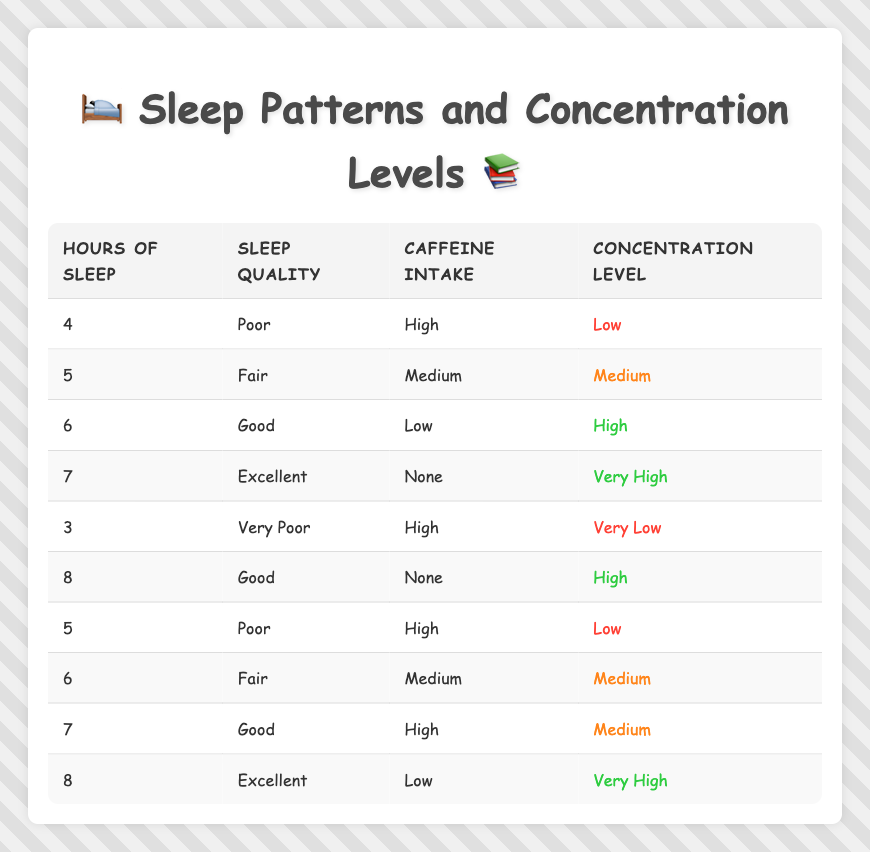What are the concentration levels associated with 4 hours of sleep? Looking at the table, under the row where "hours of sleep" is 4, the corresponding "concentration level" is listed as "low."
Answer: Low Is it true that having excellent sleep quality guarantees a very high concentration level? Yes, in the rows where sleep quality is marked as "excellent," the concentration levels are "very high" for both 7 and 8 hours of sleep. Therefore, it is true that excellent sleep quality correlates with very high concentration levels.
Answer: Yes How does an increase in caffeine intake affect concentration levels when sleep quality is poor? In the table, for "poor" sleep quality and "high" caffeine intake, the concentration is "low" (5 hours) and also "low" for 4 hours, indicating that high caffeine intake does not improve concentration when sleep quality is poor.
Answer: Low What is the average concentration level for sleep durations of 6 hours? There are two entries for "6 hours of sleep." One has "Good" quality and "Low" caffeine, resulting in a "high" concentration level. The second has "Fair" quality and "Medium" caffeine, resulting in a "medium" concentration level. The average would be calculated as follows: (high + medium) = (high is 3/5 and medium is 2/5, equivalent to (3+2)/2) = 2.5  So the average concentration level for 6 hours is "medium.”
Answer: Medium If a person sleeps for 8 hours and consumes no caffeine, what would you expect their concentration level to be? Referring to the table, for 8 hours of sleep with "Good" and "Excellent" quality and "none" caffeine intake, the "concentration level" is "high" and "very high" respectively. Thus, we can expect that 8 hours of sleep with no caffeine would likely lead to a high concentration level.
Answer: High Are there any cases where sleeping for 5 hours results in high concentration levels? From the table, there are two entries for 5 hours of sleep. Both show concentration levels to be "medium" and "low." Therefore, there are no cases where sleeping for 5 hours results in high concentration levels.
Answer: No What is the relationship between hours of sleep and concentration level when sleep quality is fair? For "fair" sleep quality, there are two data points: 5 hours has a "medium" concentration level, and 6 hours has a "medium" concentration level as well. This suggests that for fair sleep quality, concentration levels remain consistent and moderate.
Answer: Medium What would likely happen to the concentration level if someone with very poor sleep quality also drinks high amounts of caffeine? According to the table, for 3 hours of very poor sleep quality and high caffeine intake, the concentration level is "very low." This would indicate that combining very poor sleep quality with high caffeine does not improve concentration.
Answer: Very low How many data points show a concentration level of very high? In the table, there are 2 entries where the concentration level is "very high," one corresponds to 7 hours of excellent quality sleep and the other to 8 hours of excellent quality sleep as well.
Answer: 2 